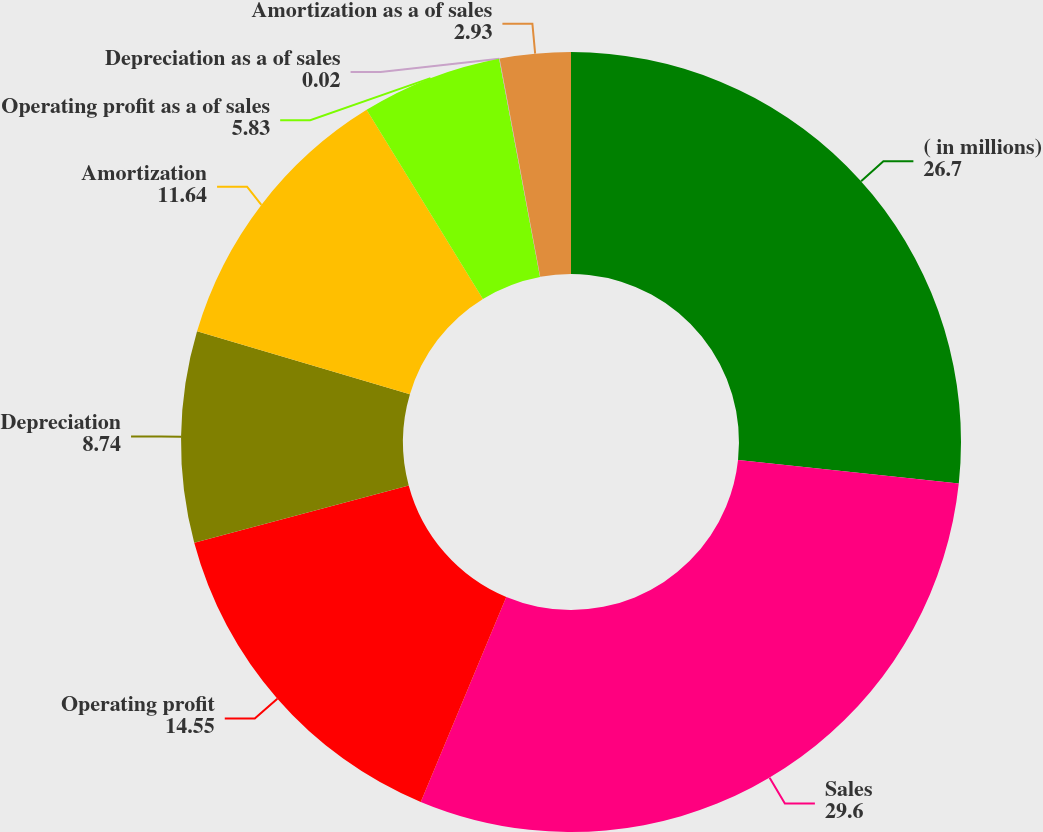Convert chart. <chart><loc_0><loc_0><loc_500><loc_500><pie_chart><fcel>( in millions)<fcel>Sales<fcel>Operating profit<fcel>Depreciation<fcel>Amortization<fcel>Operating profit as a of sales<fcel>Depreciation as a of sales<fcel>Amortization as a of sales<nl><fcel>26.7%<fcel>29.6%<fcel>14.55%<fcel>8.74%<fcel>11.64%<fcel>5.83%<fcel>0.02%<fcel>2.93%<nl></chart> 